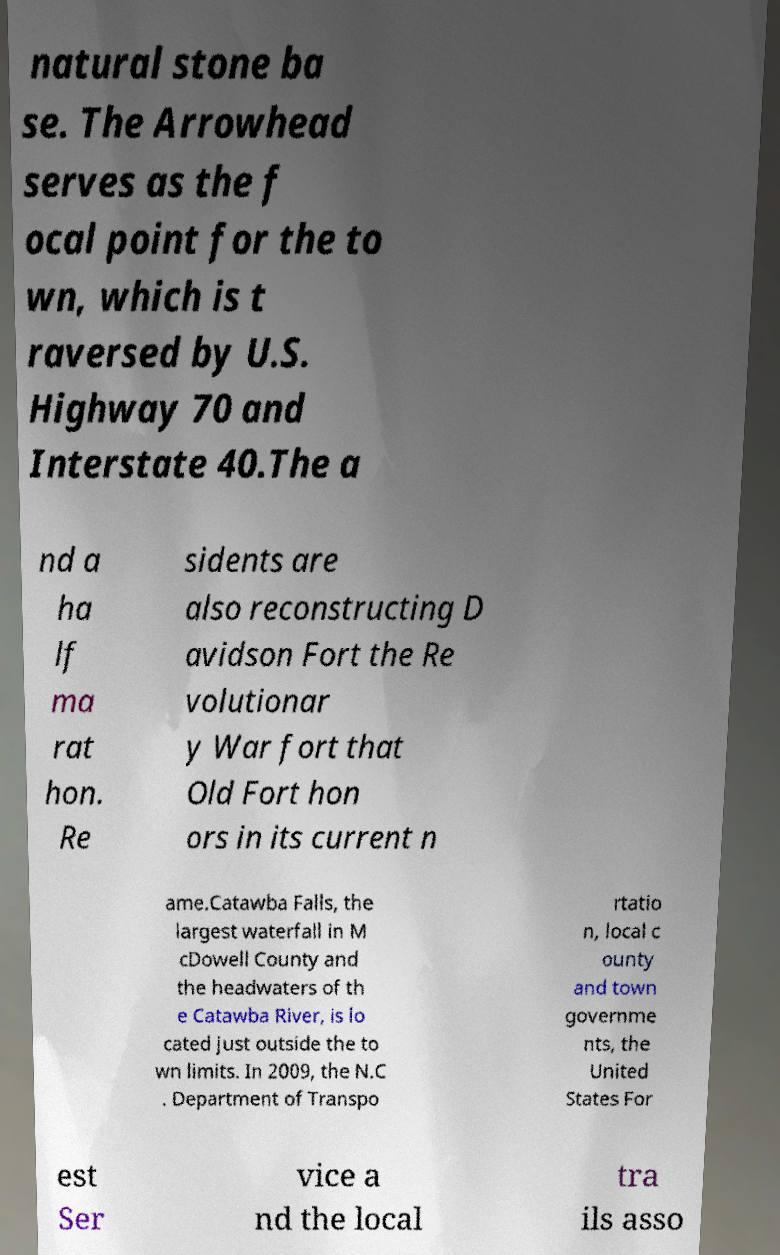For documentation purposes, I need the text within this image transcribed. Could you provide that? natural stone ba se. The Arrowhead serves as the f ocal point for the to wn, which is t raversed by U.S. Highway 70 and Interstate 40.The a nd a ha lf ma rat hon. Re sidents are also reconstructing D avidson Fort the Re volutionar y War fort that Old Fort hon ors in its current n ame.Catawba Falls, the largest waterfall in M cDowell County and the headwaters of th e Catawba River, is lo cated just outside the to wn limits. In 2009, the N.C . Department of Transpo rtatio n, local c ounty and town governme nts, the United States For est Ser vice a nd the local tra ils asso 